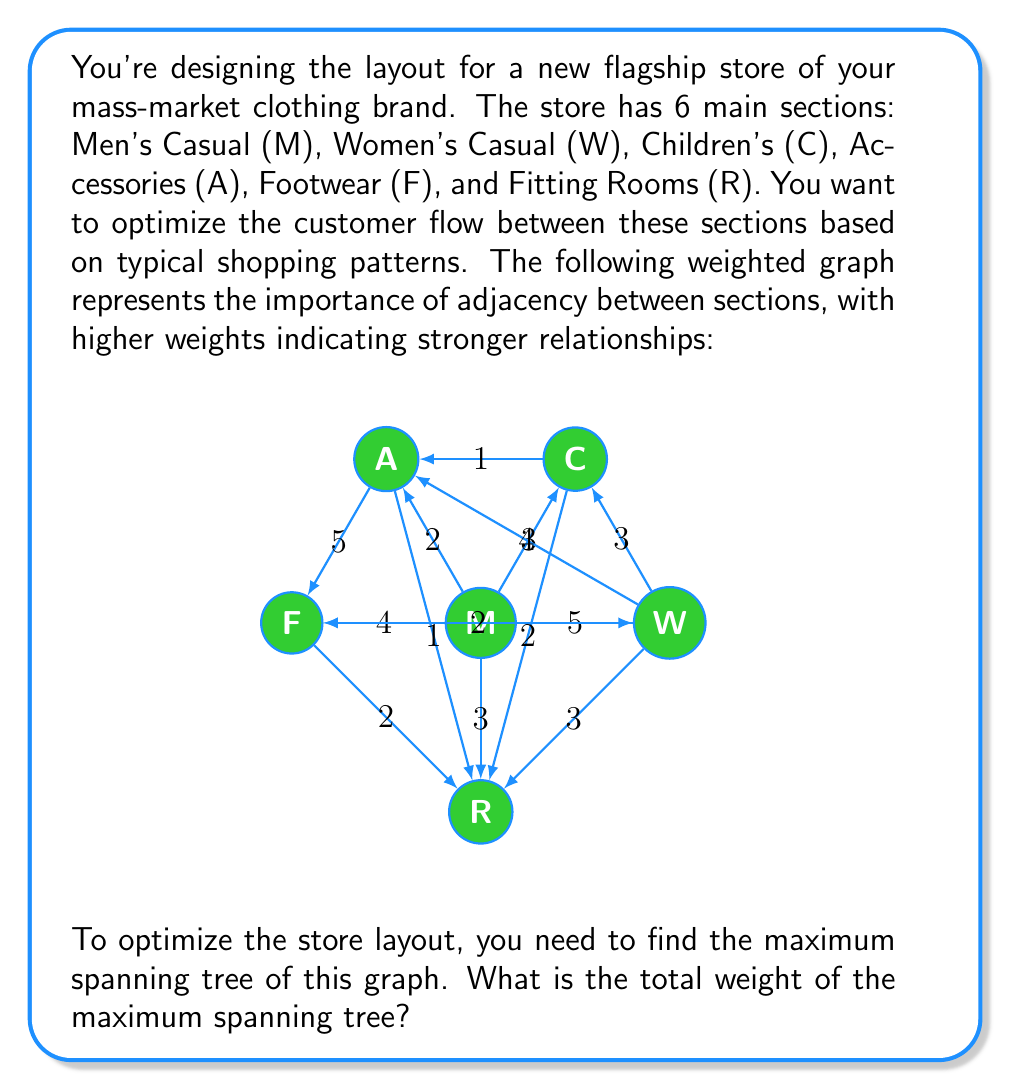Help me with this question. To solve this problem, we need to find the maximum spanning tree (MST) of the given weighted graph. The maximum spanning tree is a tree that includes all vertices of the graph and maximizes the total weight of the edges. We can use Kruskal's algorithm, but instead of selecting the minimum weight edge at each step, we'll select the maximum weight edge.

Let's apply the algorithm:

1. Sort all edges by weight in descending order:
   (M-W, A-F): 5
   (M-F): 4
   (W-A): 4
   (M-C, M-R, W-C, W-R): 3
   (M-A, C-R, F-R): 2
   (C-A, A-R): 1

2. Start with an empty set of edges and add edges in order, skipping any that would create a cycle:

   - Add (M-W): 5
   - Add (A-F): 5
   - Add (M-F): 4
   - Add (W-A): 4
   - Skip (M-C) as it would create a cycle
   - Add (M-R): 3
   - Skip (W-C) as it would create a cycle
   - Skip (W-R) as it would create a cycle
   - Skip (M-A) as it would create a cycle
   - Add (C-R): 2

3. We now have 5 edges, which is correct for a spanning tree of a 6-vertex graph.

4. Calculate the total weight:
   $$ 5 + 5 + 4 + 4 + 3 + 2 = 23 $$

Therefore, the total weight of the maximum spanning tree is 23.

This layout ensures that the most important section relationships are preserved, optimizing the customer flow through your store.
Answer: The total weight of the maximum spanning tree is 23. 